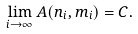<formula> <loc_0><loc_0><loc_500><loc_500>\lim _ { i \to \infty } A ( n _ { i } , m _ { i } ) = C .</formula> 